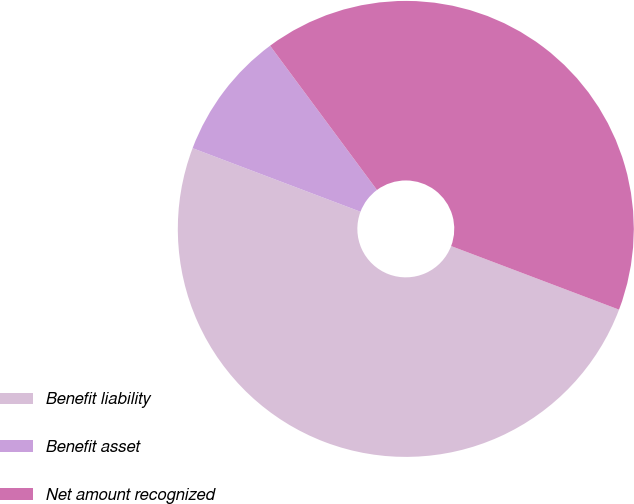Convert chart to OTSL. <chart><loc_0><loc_0><loc_500><loc_500><pie_chart><fcel>Benefit liability<fcel>Benefit asset<fcel>Net amount recognized<nl><fcel>50.0%<fcel>9.09%<fcel>40.91%<nl></chart> 